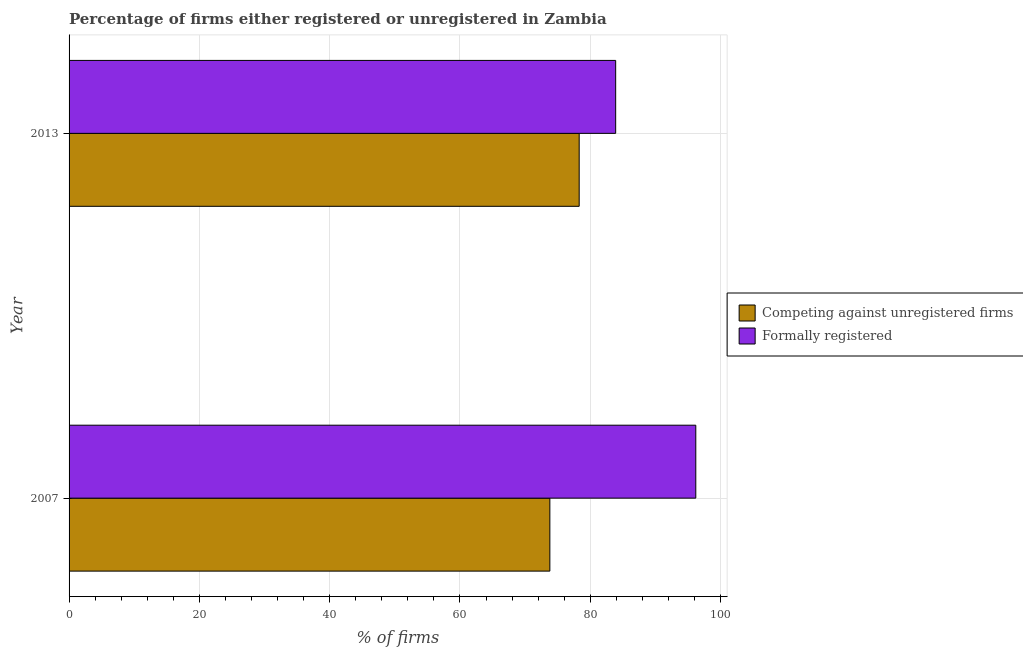How many bars are there on the 1st tick from the top?
Keep it short and to the point. 2. What is the label of the 1st group of bars from the top?
Provide a succinct answer. 2013. What is the percentage of formally registered firms in 2013?
Keep it short and to the point. 83.9. Across all years, what is the maximum percentage of registered firms?
Your response must be concise. 78.3. Across all years, what is the minimum percentage of registered firms?
Give a very brief answer. 73.8. In which year was the percentage of formally registered firms minimum?
Ensure brevity in your answer.  2013. What is the total percentage of formally registered firms in the graph?
Your answer should be very brief. 180.1. What is the difference between the percentage of formally registered firms in 2007 and the percentage of registered firms in 2013?
Provide a succinct answer. 17.9. What is the average percentage of registered firms per year?
Make the answer very short. 76.05. In how many years, is the percentage of formally registered firms greater than 68 %?
Provide a succinct answer. 2. What is the ratio of the percentage of registered firms in 2007 to that in 2013?
Give a very brief answer. 0.94. Is the difference between the percentage of formally registered firms in 2007 and 2013 greater than the difference between the percentage of registered firms in 2007 and 2013?
Make the answer very short. Yes. In how many years, is the percentage of formally registered firms greater than the average percentage of formally registered firms taken over all years?
Your response must be concise. 1. What does the 2nd bar from the top in 2013 represents?
Provide a succinct answer. Competing against unregistered firms. What does the 1st bar from the bottom in 2013 represents?
Provide a short and direct response. Competing against unregistered firms. How many years are there in the graph?
Keep it short and to the point. 2. Where does the legend appear in the graph?
Offer a terse response. Center right. How many legend labels are there?
Provide a short and direct response. 2. How are the legend labels stacked?
Offer a terse response. Vertical. What is the title of the graph?
Your answer should be compact. Percentage of firms either registered or unregistered in Zambia. Does "Merchandise exports" appear as one of the legend labels in the graph?
Offer a terse response. No. What is the label or title of the X-axis?
Your response must be concise. % of firms. What is the % of firms in Competing against unregistered firms in 2007?
Your answer should be very brief. 73.8. What is the % of firms in Formally registered in 2007?
Offer a very short reply. 96.2. What is the % of firms of Competing against unregistered firms in 2013?
Offer a very short reply. 78.3. What is the % of firms of Formally registered in 2013?
Offer a terse response. 83.9. Across all years, what is the maximum % of firms of Competing against unregistered firms?
Provide a short and direct response. 78.3. Across all years, what is the maximum % of firms of Formally registered?
Make the answer very short. 96.2. Across all years, what is the minimum % of firms of Competing against unregistered firms?
Keep it short and to the point. 73.8. Across all years, what is the minimum % of firms of Formally registered?
Offer a very short reply. 83.9. What is the total % of firms in Competing against unregistered firms in the graph?
Provide a succinct answer. 152.1. What is the total % of firms of Formally registered in the graph?
Ensure brevity in your answer.  180.1. What is the difference between the % of firms in Competing against unregistered firms in 2007 and that in 2013?
Your answer should be very brief. -4.5. What is the difference between the % of firms of Competing against unregistered firms in 2007 and the % of firms of Formally registered in 2013?
Offer a very short reply. -10.1. What is the average % of firms of Competing against unregistered firms per year?
Provide a succinct answer. 76.05. What is the average % of firms in Formally registered per year?
Give a very brief answer. 90.05. In the year 2007, what is the difference between the % of firms in Competing against unregistered firms and % of firms in Formally registered?
Your response must be concise. -22.4. In the year 2013, what is the difference between the % of firms of Competing against unregistered firms and % of firms of Formally registered?
Give a very brief answer. -5.6. What is the ratio of the % of firms of Competing against unregistered firms in 2007 to that in 2013?
Your response must be concise. 0.94. What is the ratio of the % of firms in Formally registered in 2007 to that in 2013?
Ensure brevity in your answer.  1.15. What is the difference between the highest and the second highest % of firms in Competing against unregistered firms?
Give a very brief answer. 4.5. What is the difference between the highest and the lowest % of firms in Formally registered?
Your answer should be compact. 12.3. 